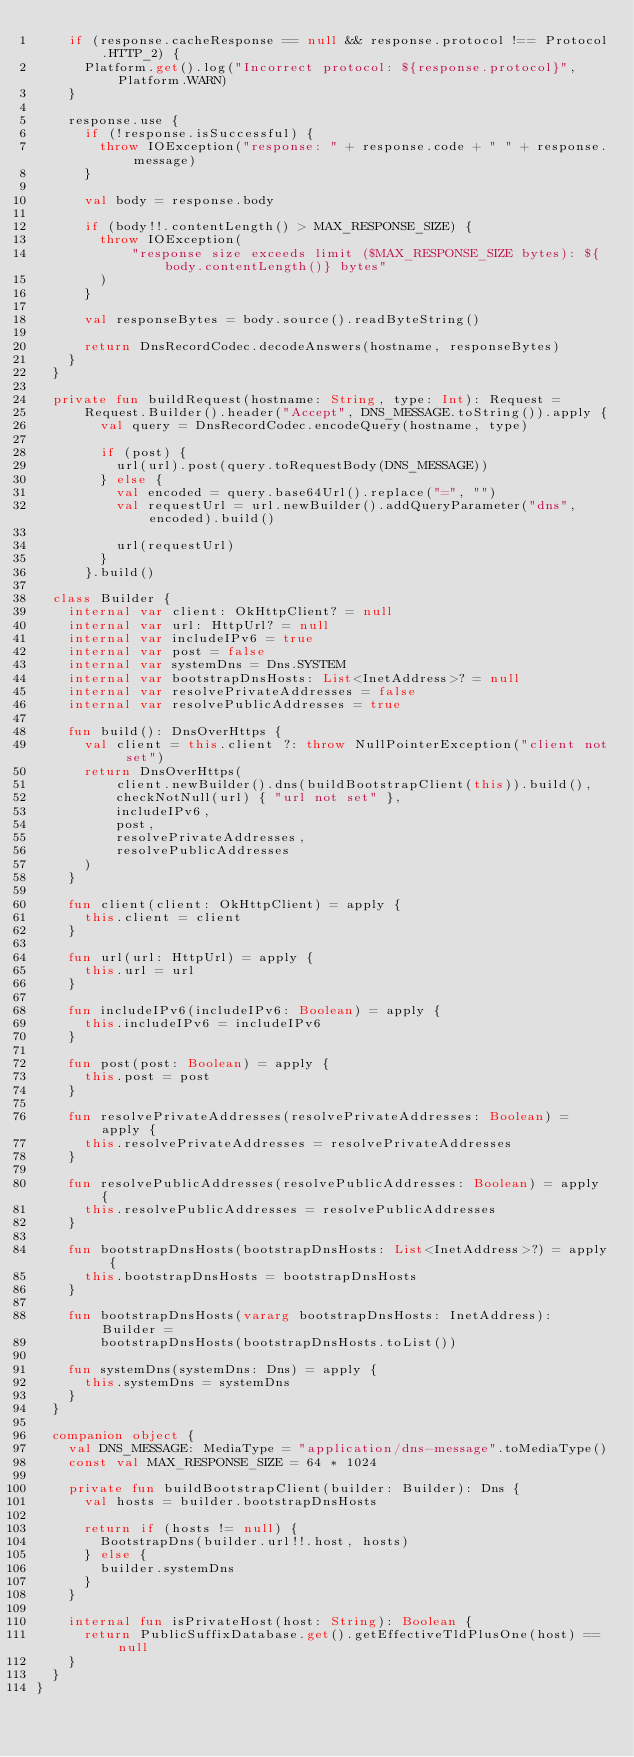<code> <loc_0><loc_0><loc_500><loc_500><_Kotlin_>    if (response.cacheResponse == null && response.protocol !== Protocol.HTTP_2) {
      Platform.get().log("Incorrect protocol: ${response.protocol}", Platform.WARN)
    }

    response.use {
      if (!response.isSuccessful) {
        throw IOException("response: " + response.code + " " + response.message)
      }

      val body = response.body

      if (body!!.contentLength() > MAX_RESPONSE_SIZE) {
        throw IOException(
            "response size exceeds limit ($MAX_RESPONSE_SIZE bytes): ${body.contentLength()} bytes"
        )
      }

      val responseBytes = body.source().readByteString()

      return DnsRecordCodec.decodeAnswers(hostname, responseBytes)
    }
  }

  private fun buildRequest(hostname: String, type: Int): Request =
      Request.Builder().header("Accept", DNS_MESSAGE.toString()).apply {
        val query = DnsRecordCodec.encodeQuery(hostname, type)

        if (post) {
          url(url).post(query.toRequestBody(DNS_MESSAGE))
        } else {
          val encoded = query.base64Url().replace("=", "")
          val requestUrl = url.newBuilder().addQueryParameter("dns", encoded).build()

          url(requestUrl)
        }
      }.build()

  class Builder {
    internal var client: OkHttpClient? = null
    internal var url: HttpUrl? = null
    internal var includeIPv6 = true
    internal var post = false
    internal var systemDns = Dns.SYSTEM
    internal var bootstrapDnsHosts: List<InetAddress>? = null
    internal var resolvePrivateAddresses = false
    internal var resolvePublicAddresses = true

    fun build(): DnsOverHttps {
      val client = this.client ?: throw NullPointerException("client not set")
      return DnsOverHttps(
          client.newBuilder().dns(buildBootstrapClient(this)).build(),
          checkNotNull(url) { "url not set" },
          includeIPv6,
          post,
          resolvePrivateAddresses,
          resolvePublicAddresses
      )
    }

    fun client(client: OkHttpClient) = apply {
      this.client = client
    }

    fun url(url: HttpUrl) = apply {
      this.url = url
    }

    fun includeIPv6(includeIPv6: Boolean) = apply {
      this.includeIPv6 = includeIPv6
    }

    fun post(post: Boolean) = apply {
      this.post = post
    }

    fun resolvePrivateAddresses(resolvePrivateAddresses: Boolean) = apply {
      this.resolvePrivateAddresses = resolvePrivateAddresses
    }

    fun resolvePublicAddresses(resolvePublicAddresses: Boolean) = apply {
      this.resolvePublicAddresses = resolvePublicAddresses
    }

    fun bootstrapDnsHosts(bootstrapDnsHosts: List<InetAddress>?) = apply {
      this.bootstrapDnsHosts = bootstrapDnsHosts
    }

    fun bootstrapDnsHosts(vararg bootstrapDnsHosts: InetAddress): Builder =
        bootstrapDnsHosts(bootstrapDnsHosts.toList())

    fun systemDns(systemDns: Dns) = apply {
      this.systemDns = systemDns
    }
  }

  companion object {
    val DNS_MESSAGE: MediaType = "application/dns-message".toMediaType()
    const val MAX_RESPONSE_SIZE = 64 * 1024

    private fun buildBootstrapClient(builder: Builder): Dns {
      val hosts = builder.bootstrapDnsHosts

      return if (hosts != null) {
        BootstrapDns(builder.url!!.host, hosts)
      } else {
        builder.systemDns
      }
    }

    internal fun isPrivateHost(host: String): Boolean {
      return PublicSuffixDatabase.get().getEffectiveTldPlusOne(host) == null
    }
  }
}
</code> 